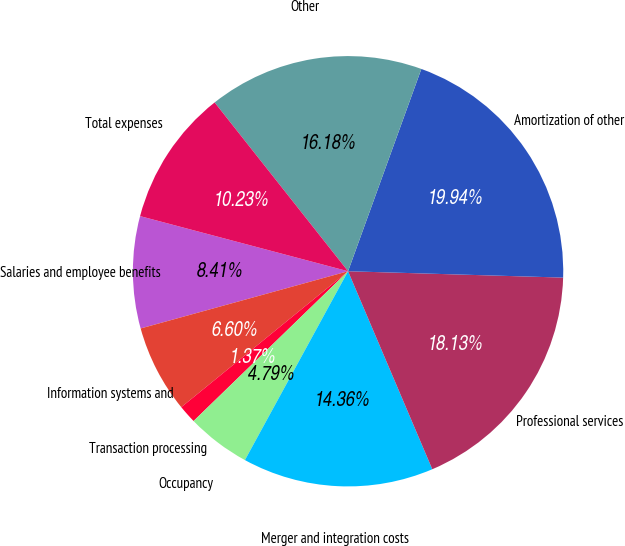<chart> <loc_0><loc_0><loc_500><loc_500><pie_chart><fcel>Salaries and employee benefits<fcel>Information systems and<fcel>Transaction processing<fcel>Occupancy<fcel>Merger and integration costs<fcel>Professional services<fcel>Amortization of other<fcel>Other<fcel>Total expenses<nl><fcel>8.41%<fcel>6.6%<fcel>1.37%<fcel>4.79%<fcel>14.36%<fcel>18.13%<fcel>19.94%<fcel>16.18%<fcel>10.23%<nl></chart> 